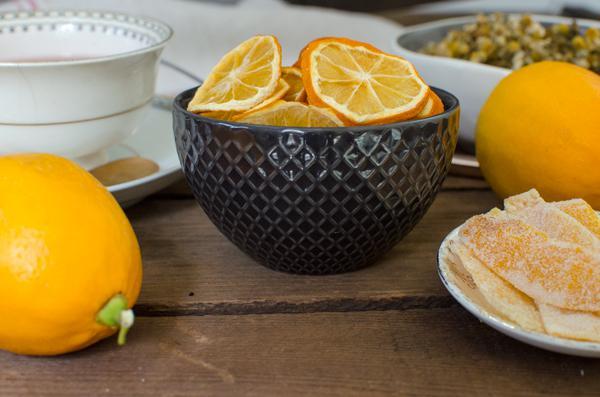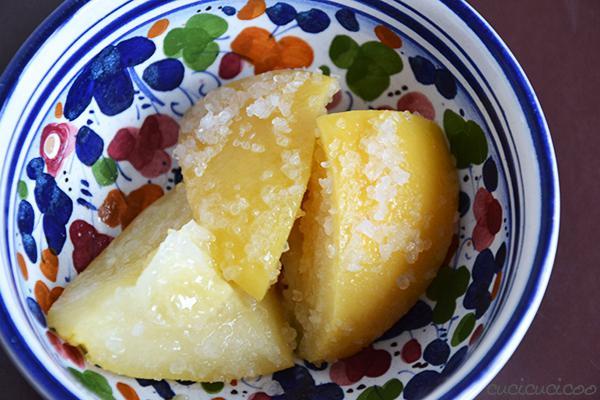The first image is the image on the left, the second image is the image on the right. Analyze the images presented: Is the assertion "Some of the lemons are not sliced." valid? Answer yes or no. Yes. The first image is the image on the left, the second image is the image on the right. Analyze the images presented: Is the assertion "There are dried sliced oranges in a back bowl on a wooden table, there is a tea cup next to the bowl" valid? Answer yes or no. Yes. 